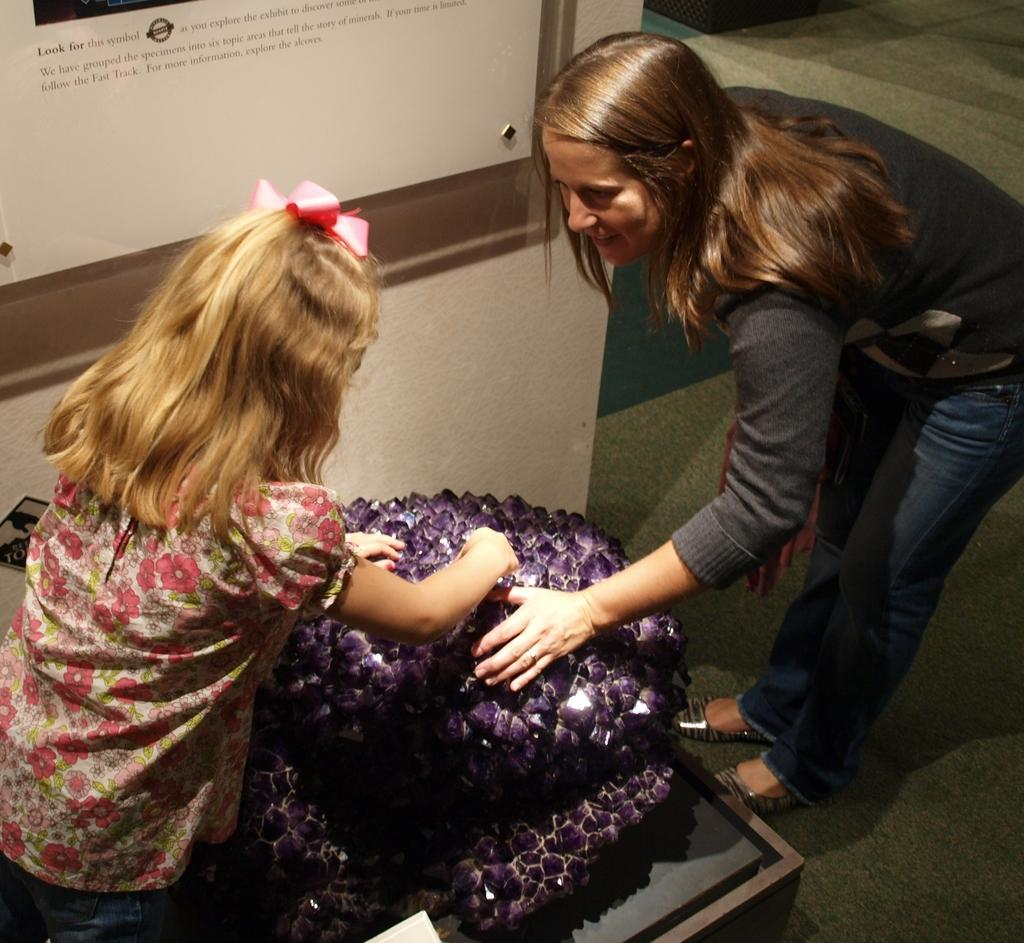What can be seen in the background of the image? There is a wall in the image. Is there any object in the image that typically holds a picture or photograph? Yes, there is a photo frame in the image. How many people are present in the image? There are two people standing in the image. Can you describe the gender of one of the individuals? One of the people is a woman. Where is the woman positioned in the image? The woman is on the right side of the image. What color is the dress the woman is wearing? The woman is wearing a black color dress. What type of skin condition can be seen on the woman's face in the image? There is no indication of any skin condition on the woman's face in the image. What answer is the woman providing in the image? The image does not show the woman providing any answer, as it is a still photograph. 